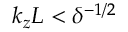Convert formula to latex. <formula><loc_0><loc_0><loc_500><loc_500>k _ { z } L < \delta ^ { - 1 / 2 }</formula> 